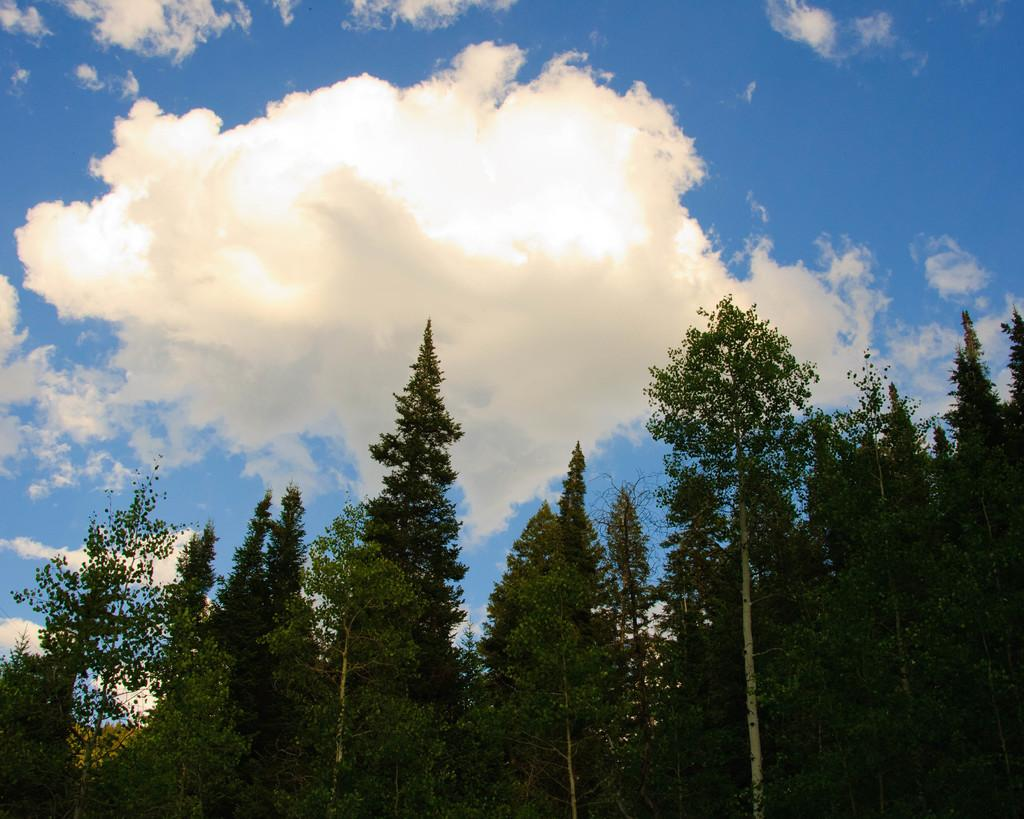What type of vegetation can be seen in the image? There are trees in the image. What is the condition of the sky in the image? The sky is cloudy in the image. What type of metal can be seen in the image? There is no metal present in the image; it features trees and a cloudy sky. What action is being performed by the arm in the image? There is no arm present in the image, as it only features trees and a cloudy sky. 